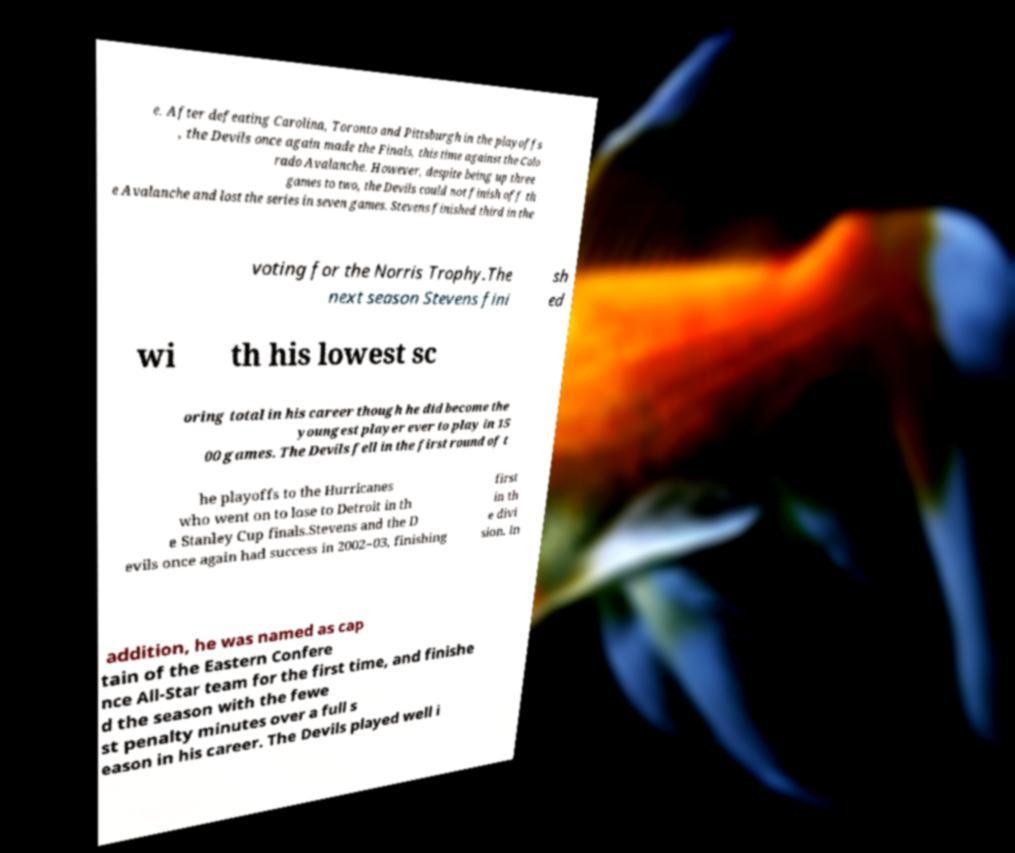Could you extract and type out the text from this image? e. After defeating Carolina, Toronto and Pittsburgh in the playoffs , the Devils once again made the Finals, this time against the Colo rado Avalanche. However, despite being up three games to two, the Devils could not finish off th e Avalanche and lost the series in seven games. Stevens finished third in the voting for the Norris Trophy.The next season Stevens fini sh ed wi th his lowest sc oring total in his career though he did become the youngest player ever to play in 15 00 games. The Devils fell in the first round of t he playoffs to the Hurricanes who went on to lose to Detroit in th e Stanley Cup finals.Stevens and the D evils once again had success in 2002–03, finishing first in th e divi sion. In addition, he was named as cap tain of the Eastern Confere nce All-Star team for the first time, and finishe d the season with the fewe st penalty minutes over a full s eason in his career. The Devils played well i 